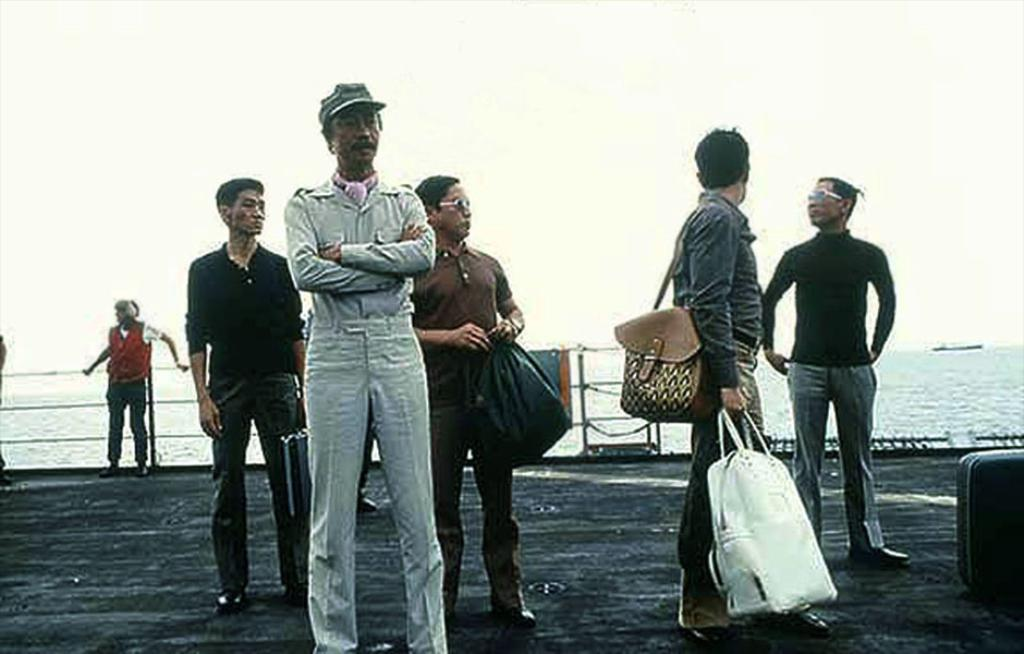What is happening in the foreground of the image? There are people standing on the land in the image. What can be seen in the distance behind the people? There is an ocean visible in the background of the image. What else is visible in the background of the image? The sky is visible in the background of the image. How many times does the person in the image cough before they continue walking? There is no person in the image coughing or walking; the image only shows people standing on the land with an ocean and sky visible in the background. 